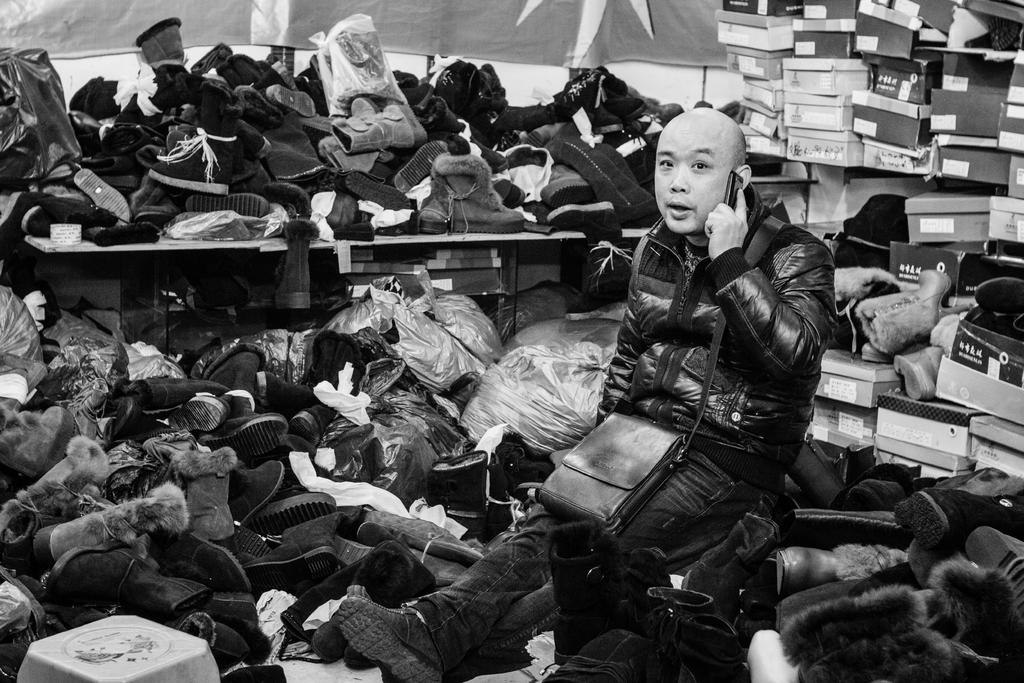What is the man in the image doing? The man is sitting in the center of the image. What is the man holding in the image? The man is holding a mobile. What is the man wearing in the image? The man is wearing a bag. What can be seen in the background of the image? There are shoes, a table, and boxes in the background of the image. What time of day is it in the image, given the presence of the morning sun? There is no mention of the sun or time of day in the image, so it cannot be determined from the image alone. 